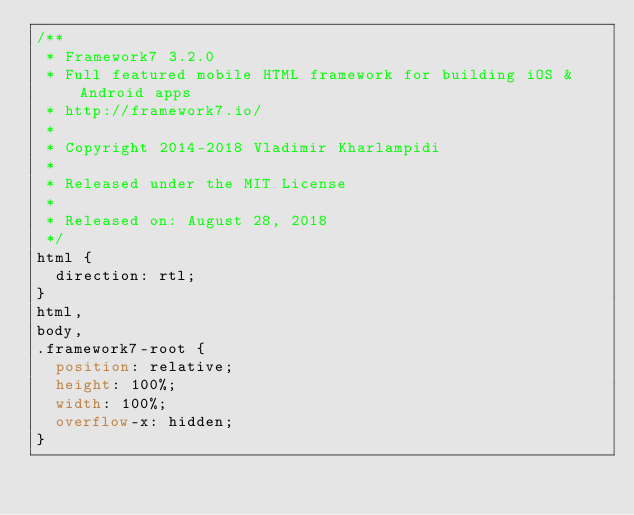Convert code to text. <code><loc_0><loc_0><loc_500><loc_500><_CSS_>/**
 * Framework7 3.2.0
 * Full featured mobile HTML framework for building iOS & Android apps
 * http://framework7.io/
 *
 * Copyright 2014-2018 Vladimir Kharlampidi
 *
 * Released under the MIT License
 *
 * Released on: August 28, 2018
 */
html {
  direction: rtl;
}
html,
body,
.framework7-root {
  position: relative;
  height: 100%;
  width: 100%;
  overflow-x: hidden;
}</code> 